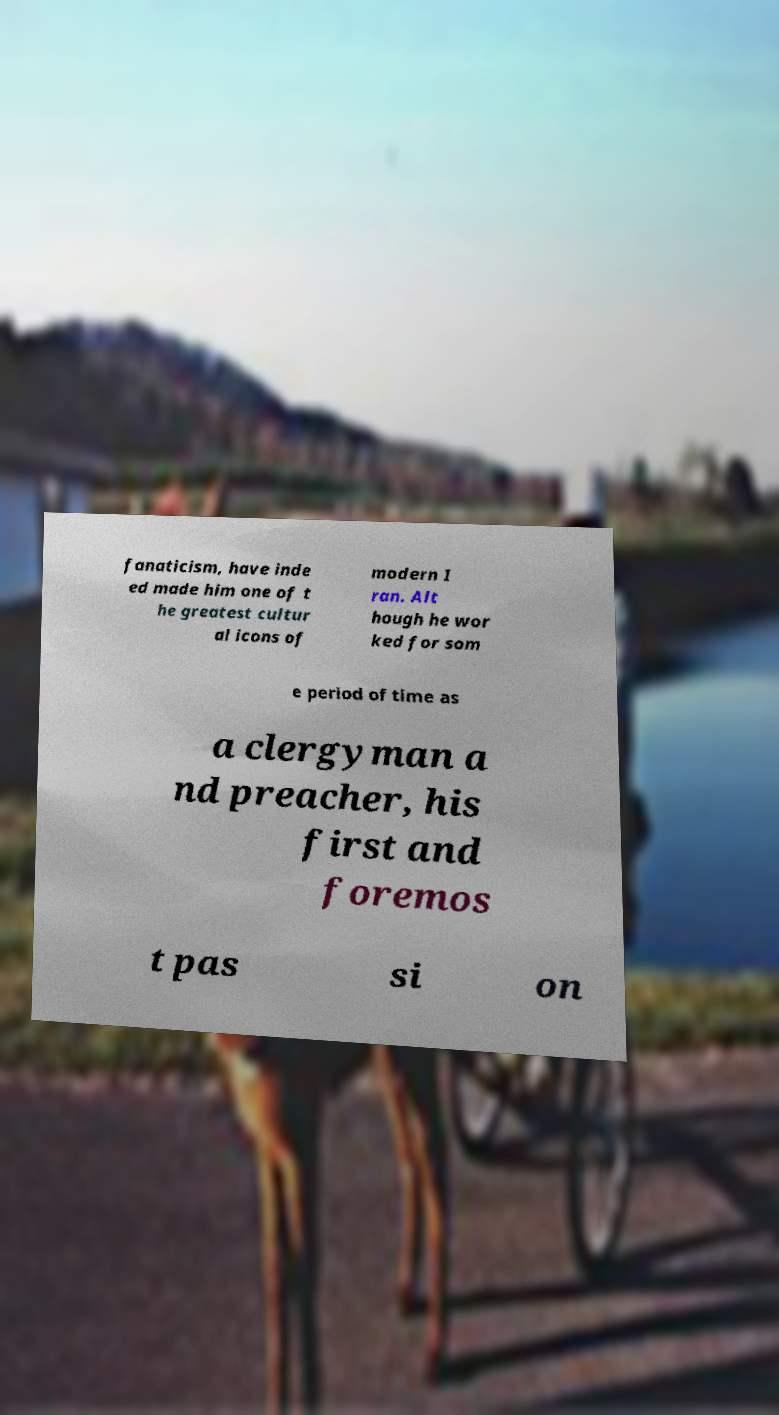What messages or text are displayed in this image? I need them in a readable, typed format. fanaticism, have inde ed made him one of t he greatest cultur al icons of modern I ran. Alt hough he wor ked for som e period of time as a clergyman a nd preacher, his first and foremos t pas si on 